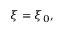Convert formula to latex. <formula><loc_0><loc_0><loc_500><loc_500>\xi = \xi _ { 0 } ,</formula> 